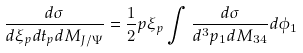Convert formula to latex. <formula><loc_0><loc_0><loc_500><loc_500>\frac { d \sigma } { d \xi _ { p } d t _ { p } d M _ { J / \Psi } } = \frac { 1 } { 2 } p \xi _ { p } \int \frac { d \sigma } { d ^ { 3 } p _ { 1 } d M _ { 3 4 } } d \phi _ { 1 }</formula> 